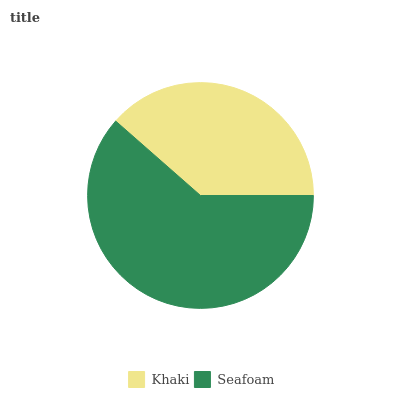Is Khaki the minimum?
Answer yes or no. Yes. Is Seafoam the maximum?
Answer yes or no. Yes. Is Seafoam the minimum?
Answer yes or no. No. Is Seafoam greater than Khaki?
Answer yes or no. Yes. Is Khaki less than Seafoam?
Answer yes or no. Yes. Is Khaki greater than Seafoam?
Answer yes or no. No. Is Seafoam less than Khaki?
Answer yes or no. No. Is Seafoam the high median?
Answer yes or no. Yes. Is Khaki the low median?
Answer yes or no. Yes. Is Khaki the high median?
Answer yes or no. No. Is Seafoam the low median?
Answer yes or no. No. 